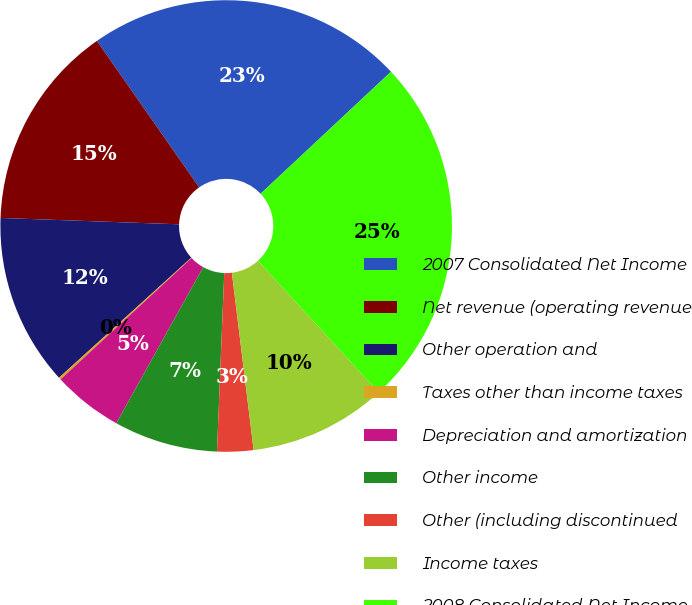Convert chart to OTSL. <chart><loc_0><loc_0><loc_500><loc_500><pie_chart><fcel>2007 Consolidated Net Income<fcel>Net revenue (operating revenue<fcel>Other operation and<fcel>Taxes other than income taxes<fcel>Depreciation and amortization<fcel>Other income<fcel>Other (including discontinued<fcel>Income taxes<fcel>2008 Consolidated Net Income<nl><fcel>22.73%<fcel>14.73%<fcel>12.3%<fcel>0.16%<fcel>5.02%<fcel>7.44%<fcel>2.59%<fcel>9.87%<fcel>25.16%<nl></chart> 